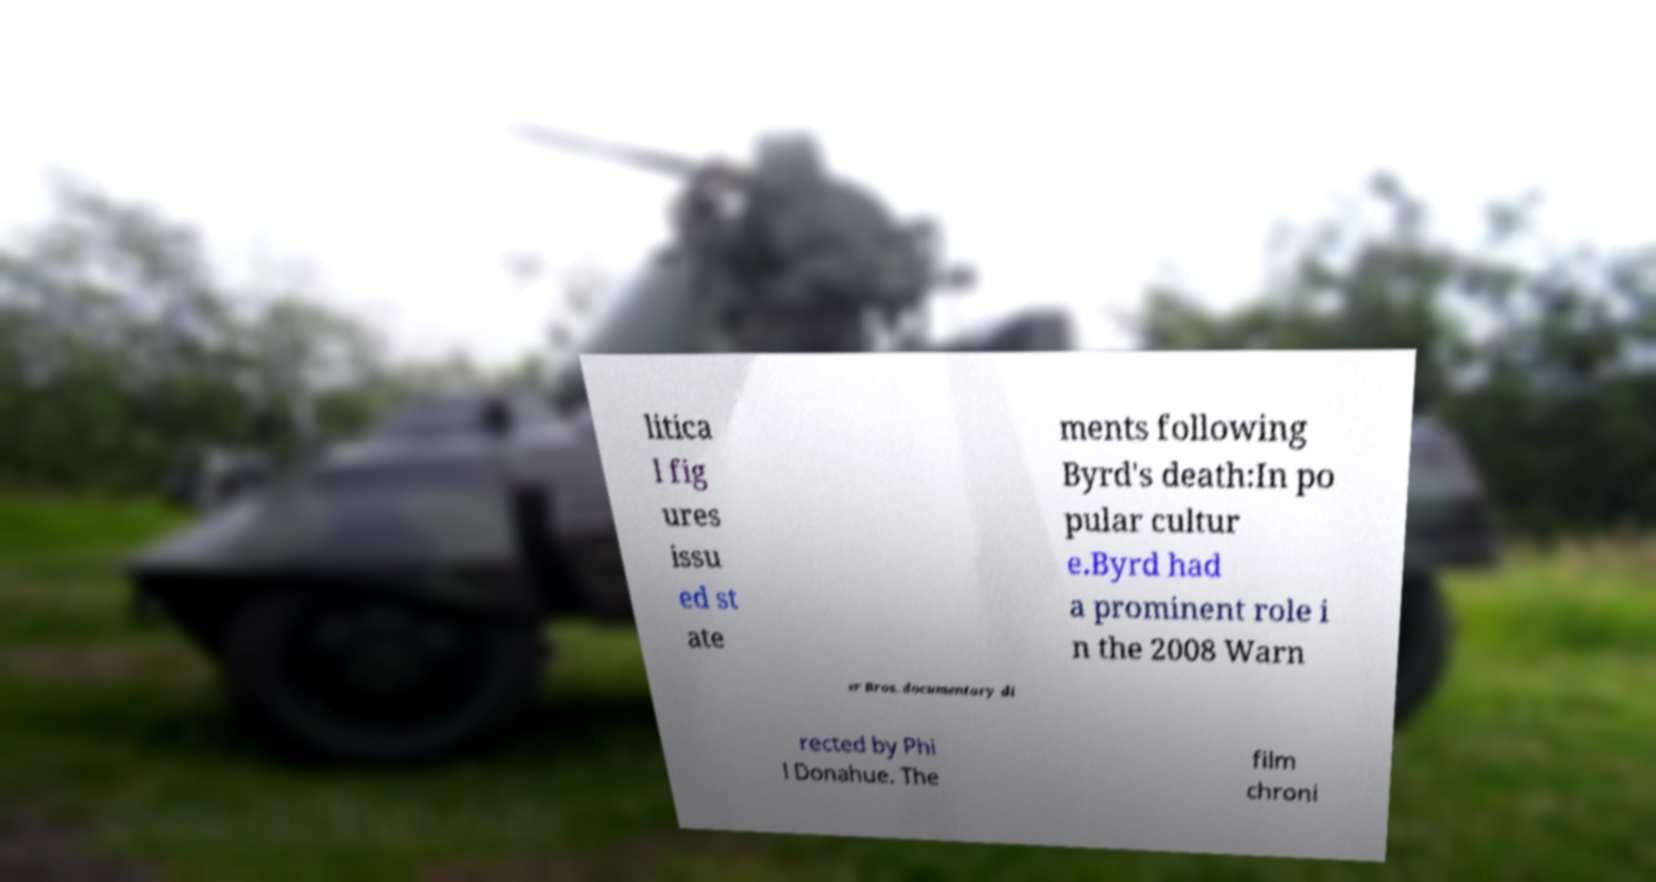For documentation purposes, I need the text within this image transcribed. Could you provide that? litica l fig ures issu ed st ate ments following Byrd's death:In po pular cultur e.Byrd had a prominent role i n the 2008 Warn er Bros. documentary di rected by Phi l Donahue. The film chroni 